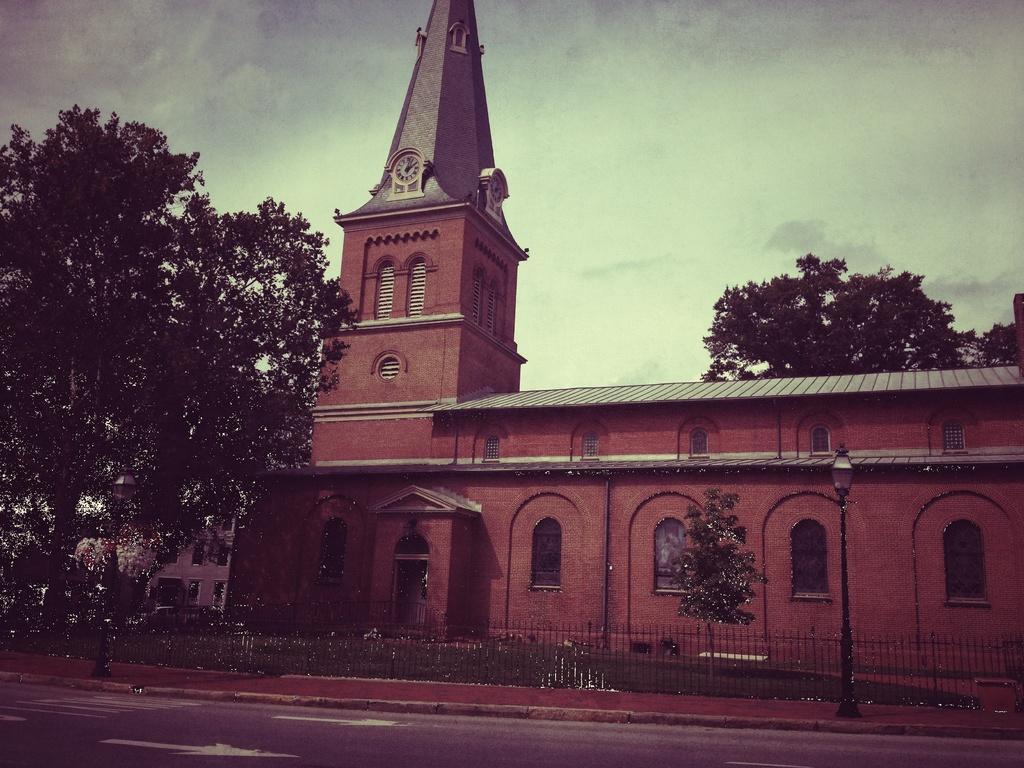Can you describe this image briefly? In this image we can see a building, on the building, we can see a clock, there are some windows, poles, lights, trees, grass and fence, in the background, we can see the sky with clouds. 